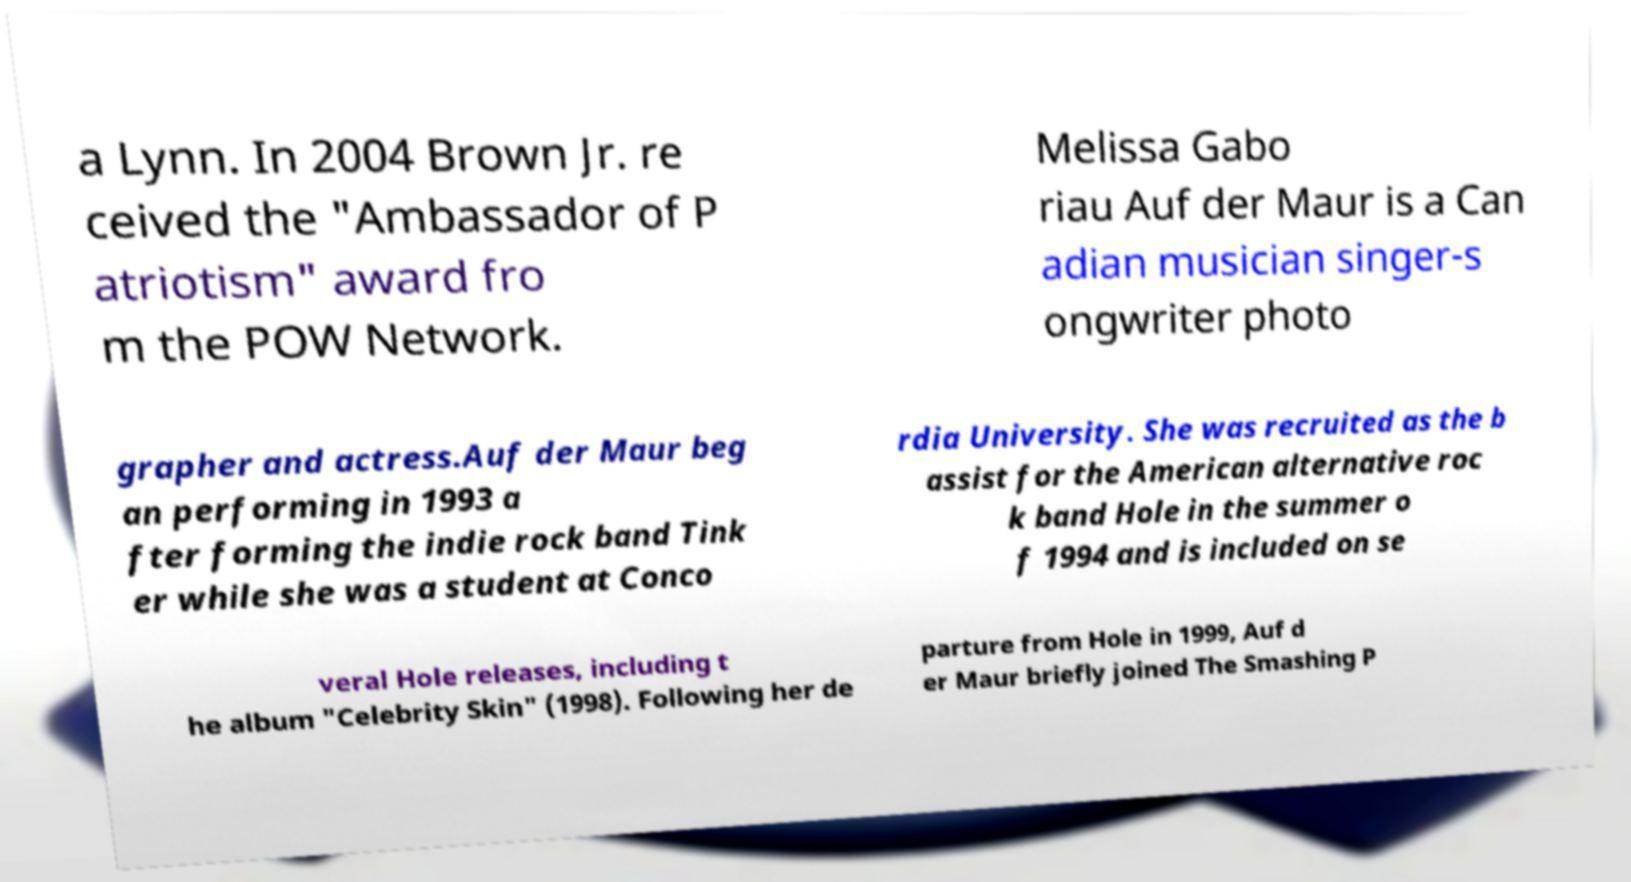Could you assist in decoding the text presented in this image and type it out clearly? a Lynn. In 2004 Brown Jr. re ceived the "Ambassador of P atriotism" award fro m the POW Network. Melissa Gabo riau Auf der Maur is a Can adian musician singer-s ongwriter photo grapher and actress.Auf der Maur beg an performing in 1993 a fter forming the indie rock band Tink er while she was a student at Conco rdia University. She was recruited as the b assist for the American alternative roc k band Hole in the summer o f 1994 and is included on se veral Hole releases, including t he album "Celebrity Skin" (1998). Following her de parture from Hole in 1999, Auf d er Maur briefly joined The Smashing P 